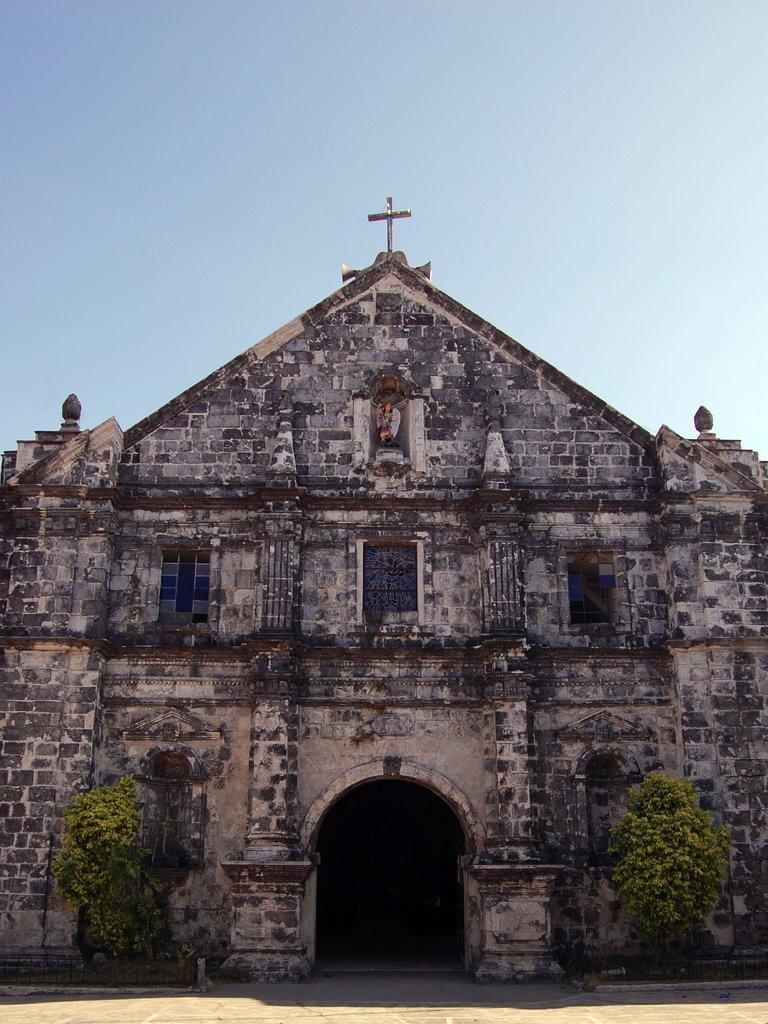What type of building is in the image? There is a church in the image. What can be seen at the bottom of the image? Trees are present at the bottom of the image. What is visible in the background of the image? The sky is visible in the background of the image. What type of game is being played in the churchyard in the image? There is no game being played in the image; it only shows a church, trees, and the sky. 